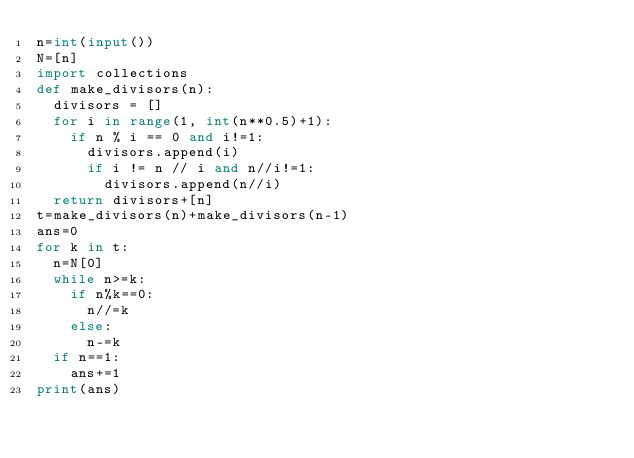<code> <loc_0><loc_0><loc_500><loc_500><_Python_>n=int(input())
N=[n]
import collections
def make_divisors(n):
  divisors = []
  for i in range(1, int(n**0.5)+1):
    if n % i == 0 and i!=1:
      divisors.append(i)
      if i != n // i and n//i!=1:
        divisors.append(n//i)
  return divisors+[n]
t=make_divisors(n)+make_divisors(n-1)
ans=0
for k in t:
  n=N[0]
  while n>=k:
    if n%k==0:
      n//=k
    else:
      n-=k
  if n==1:
    ans+=1
print(ans)</code> 